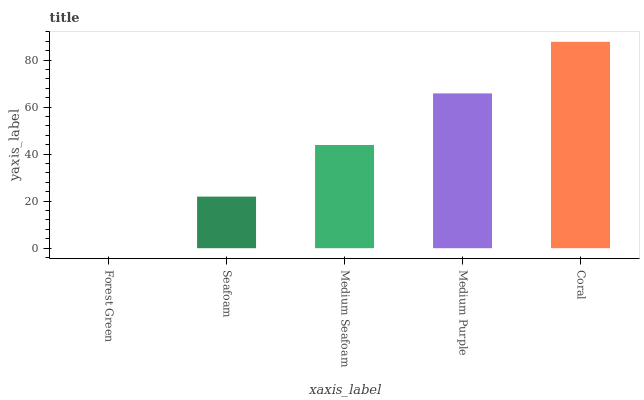Is Forest Green the minimum?
Answer yes or no. Yes. Is Coral the maximum?
Answer yes or no. Yes. Is Seafoam the minimum?
Answer yes or no. No. Is Seafoam the maximum?
Answer yes or no. No. Is Seafoam greater than Forest Green?
Answer yes or no. Yes. Is Forest Green less than Seafoam?
Answer yes or no. Yes. Is Forest Green greater than Seafoam?
Answer yes or no. No. Is Seafoam less than Forest Green?
Answer yes or no. No. Is Medium Seafoam the high median?
Answer yes or no. Yes. Is Medium Seafoam the low median?
Answer yes or no. Yes. Is Medium Purple the high median?
Answer yes or no. No. Is Forest Green the low median?
Answer yes or no. No. 